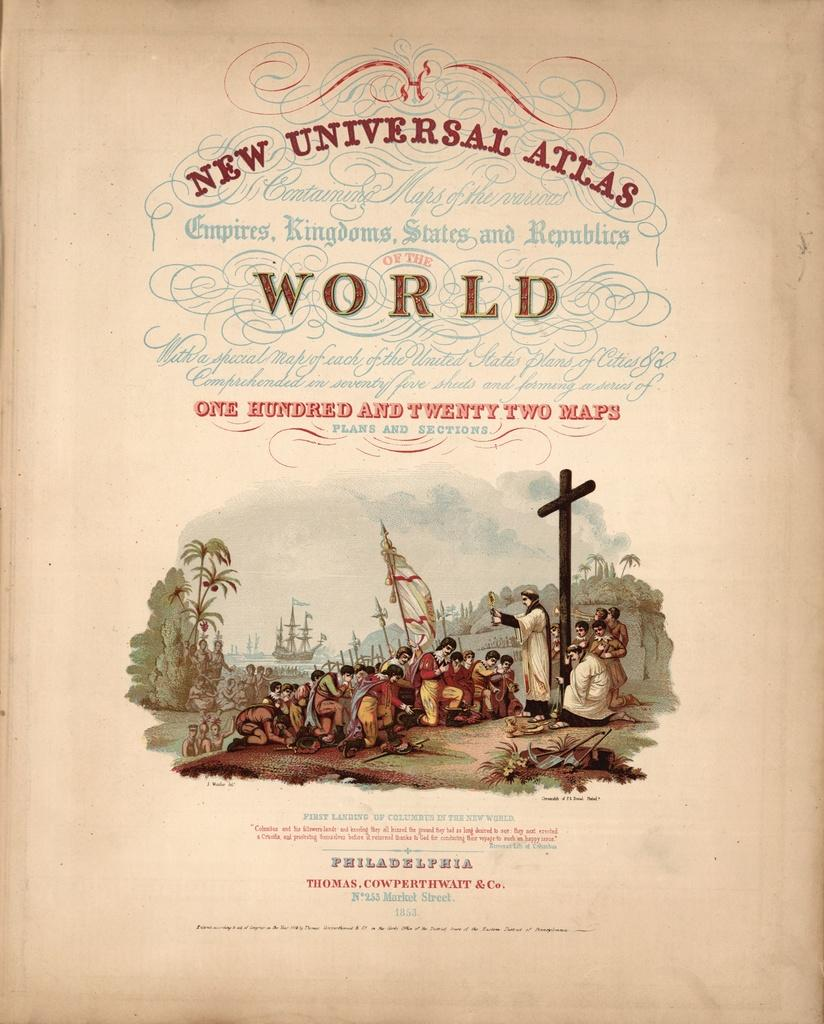Provide a one-sentence caption for the provided image. The cover of a book that is titled New Universal Atlas. 